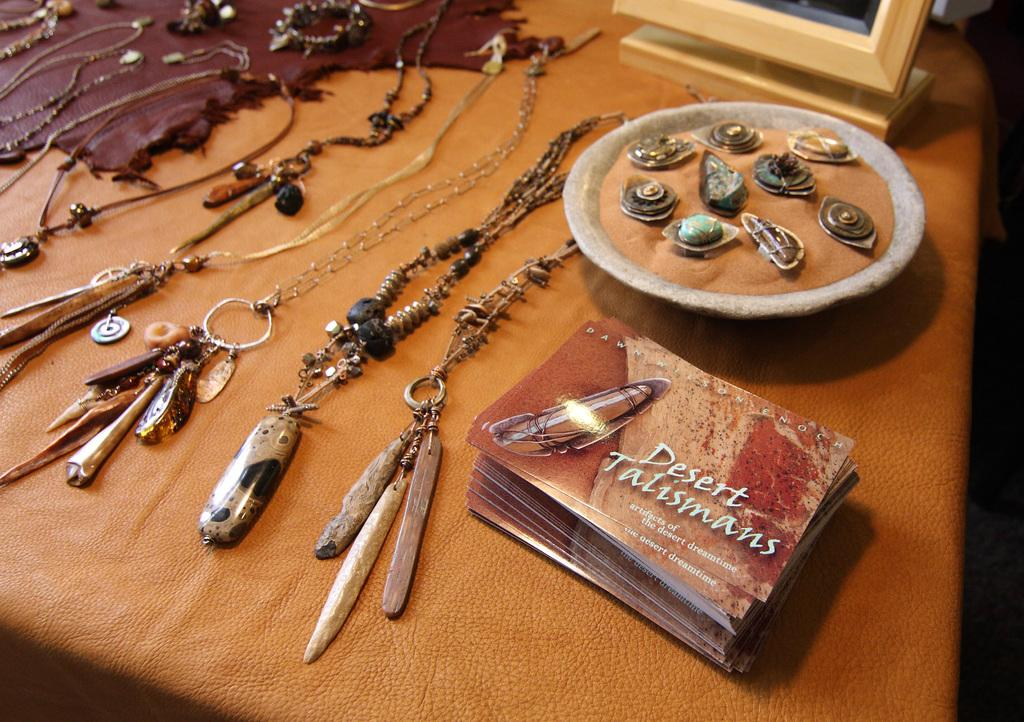Provide a one-sentence caption for the provided image. The Desert Talisman sits on a table next to several pieces of jewelry. 